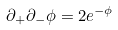Convert formula to latex. <formula><loc_0><loc_0><loc_500><loc_500>\partial _ { + } \partial _ { - } \phi = 2 e ^ { - \phi }</formula> 